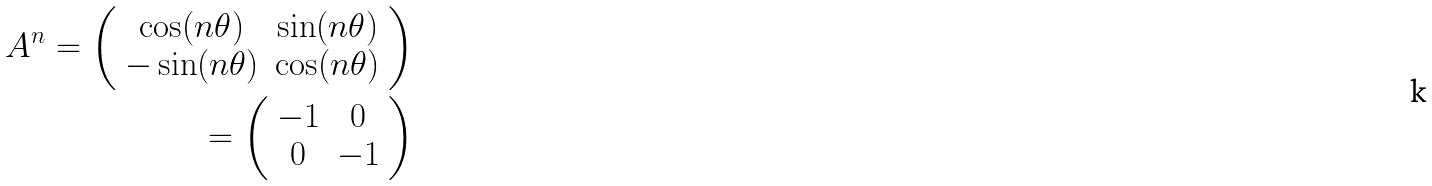<formula> <loc_0><loc_0><loc_500><loc_500>A ^ { n } = \left ( \begin{array} { c c } \cos ( n \theta ) & \sin ( n \theta ) \\ - \sin ( n \theta ) & \cos ( n \theta ) \end{array} \right ) \\ = \left ( \begin{array} { c c } - 1 & 0 \\ 0 & - 1 \end{array} \right )</formula> 